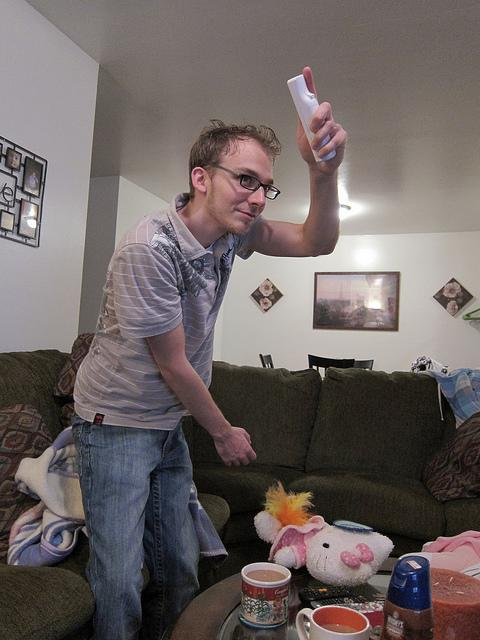What type of remote is the man holding? Please explain your reasoning. nintendo wii. The remote is for wii. 